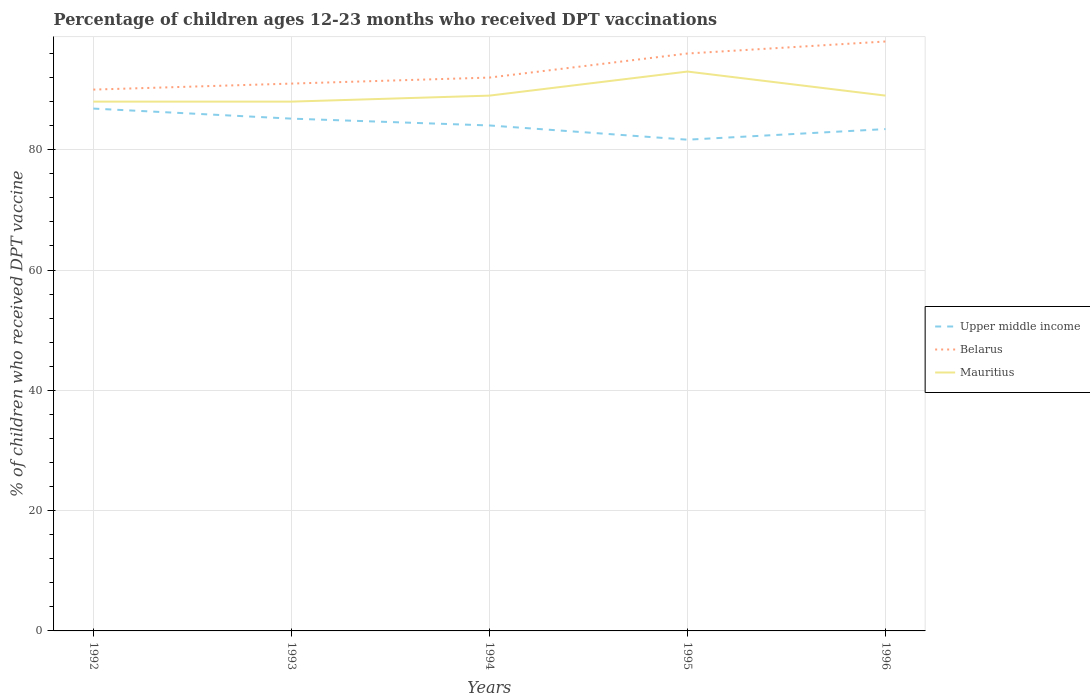How many different coloured lines are there?
Provide a succinct answer. 3. Does the line corresponding to Belarus intersect with the line corresponding to Mauritius?
Offer a very short reply. No. Is the number of lines equal to the number of legend labels?
Your answer should be very brief. Yes. Across all years, what is the maximum percentage of children who received DPT vaccination in Mauritius?
Provide a short and direct response. 88. What is the difference between the highest and the second highest percentage of children who received DPT vaccination in Mauritius?
Offer a terse response. 5. What is the difference between the highest and the lowest percentage of children who received DPT vaccination in Mauritius?
Your answer should be very brief. 1. Are the values on the major ticks of Y-axis written in scientific E-notation?
Offer a terse response. No. Does the graph contain any zero values?
Ensure brevity in your answer.  No. Does the graph contain grids?
Your answer should be compact. Yes. Where does the legend appear in the graph?
Keep it short and to the point. Center right. How many legend labels are there?
Make the answer very short. 3. How are the legend labels stacked?
Your answer should be very brief. Vertical. What is the title of the graph?
Give a very brief answer. Percentage of children ages 12-23 months who received DPT vaccinations. Does "Tuvalu" appear as one of the legend labels in the graph?
Ensure brevity in your answer.  No. What is the label or title of the X-axis?
Give a very brief answer. Years. What is the label or title of the Y-axis?
Give a very brief answer. % of children who received DPT vaccine. What is the % of children who received DPT vaccine in Upper middle income in 1992?
Make the answer very short. 86.84. What is the % of children who received DPT vaccine of Upper middle income in 1993?
Your response must be concise. 85.17. What is the % of children who received DPT vaccine in Belarus in 1993?
Your answer should be compact. 91. What is the % of children who received DPT vaccine in Mauritius in 1993?
Offer a terse response. 88. What is the % of children who received DPT vaccine in Upper middle income in 1994?
Keep it short and to the point. 84.04. What is the % of children who received DPT vaccine in Belarus in 1994?
Your answer should be very brief. 92. What is the % of children who received DPT vaccine of Mauritius in 1994?
Provide a succinct answer. 89. What is the % of children who received DPT vaccine in Upper middle income in 1995?
Provide a short and direct response. 81.67. What is the % of children who received DPT vaccine in Belarus in 1995?
Offer a terse response. 96. What is the % of children who received DPT vaccine of Mauritius in 1995?
Your answer should be compact. 93. What is the % of children who received DPT vaccine in Upper middle income in 1996?
Offer a terse response. 83.43. What is the % of children who received DPT vaccine of Mauritius in 1996?
Your answer should be very brief. 89. Across all years, what is the maximum % of children who received DPT vaccine in Upper middle income?
Give a very brief answer. 86.84. Across all years, what is the maximum % of children who received DPT vaccine of Mauritius?
Make the answer very short. 93. Across all years, what is the minimum % of children who received DPT vaccine of Upper middle income?
Your answer should be very brief. 81.67. Across all years, what is the minimum % of children who received DPT vaccine of Mauritius?
Your answer should be very brief. 88. What is the total % of children who received DPT vaccine of Upper middle income in the graph?
Your response must be concise. 421.16. What is the total % of children who received DPT vaccine of Belarus in the graph?
Provide a short and direct response. 467. What is the total % of children who received DPT vaccine in Mauritius in the graph?
Your response must be concise. 447. What is the difference between the % of children who received DPT vaccine in Upper middle income in 1992 and that in 1993?
Make the answer very short. 1.67. What is the difference between the % of children who received DPT vaccine in Belarus in 1992 and that in 1993?
Provide a succinct answer. -1. What is the difference between the % of children who received DPT vaccine of Mauritius in 1992 and that in 1993?
Your response must be concise. 0. What is the difference between the % of children who received DPT vaccine of Upper middle income in 1992 and that in 1994?
Make the answer very short. 2.81. What is the difference between the % of children who received DPT vaccine of Belarus in 1992 and that in 1994?
Keep it short and to the point. -2. What is the difference between the % of children who received DPT vaccine in Mauritius in 1992 and that in 1994?
Provide a succinct answer. -1. What is the difference between the % of children who received DPT vaccine of Upper middle income in 1992 and that in 1995?
Ensure brevity in your answer.  5.17. What is the difference between the % of children who received DPT vaccine of Belarus in 1992 and that in 1995?
Ensure brevity in your answer.  -6. What is the difference between the % of children who received DPT vaccine in Mauritius in 1992 and that in 1995?
Ensure brevity in your answer.  -5. What is the difference between the % of children who received DPT vaccine in Upper middle income in 1992 and that in 1996?
Keep it short and to the point. 3.41. What is the difference between the % of children who received DPT vaccine in Belarus in 1992 and that in 1996?
Provide a short and direct response. -8. What is the difference between the % of children who received DPT vaccine in Upper middle income in 1993 and that in 1994?
Provide a short and direct response. 1.13. What is the difference between the % of children who received DPT vaccine in Belarus in 1993 and that in 1994?
Your answer should be compact. -1. What is the difference between the % of children who received DPT vaccine in Upper middle income in 1993 and that in 1995?
Offer a terse response. 3.5. What is the difference between the % of children who received DPT vaccine in Mauritius in 1993 and that in 1995?
Offer a terse response. -5. What is the difference between the % of children who received DPT vaccine of Upper middle income in 1993 and that in 1996?
Provide a succinct answer. 1.74. What is the difference between the % of children who received DPT vaccine of Belarus in 1993 and that in 1996?
Offer a terse response. -7. What is the difference between the % of children who received DPT vaccine in Mauritius in 1993 and that in 1996?
Offer a very short reply. -1. What is the difference between the % of children who received DPT vaccine of Upper middle income in 1994 and that in 1995?
Ensure brevity in your answer.  2.37. What is the difference between the % of children who received DPT vaccine of Belarus in 1994 and that in 1995?
Keep it short and to the point. -4. What is the difference between the % of children who received DPT vaccine in Upper middle income in 1994 and that in 1996?
Your answer should be compact. 0.6. What is the difference between the % of children who received DPT vaccine of Belarus in 1994 and that in 1996?
Offer a terse response. -6. What is the difference between the % of children who received DPT vaccine in Upper middle income in 1995 and that in 1996?
Make the answer very short. -1.76. What is the difference between the % of children who received DPT vaccine in Mauritius in 1995 and that in 1996?
Offer a terse response. 4. What is the difference between the % of children who received DPT vaccine in Upper middle income in 1992 and the % of children who received DPT vaccine in Belarus in 1993?
Offer a very short reply. -4.16. What is the difference between the % of children who received DPT vaccine of Upper middle income in 1992 and the % of children who received DPT vaccine of Mauritius in 1993?
Give a very brief answer. -1.16. What is the difference between the % of children who received DPT vaccine in Belarus in 1992 and the % of children who received DPT vaccine in Mauritius in 1993?
Your answer should be very brief. 2. What is the difference between the % of children who received DPT vaccine of Upper middle income in 1992 and the % of children who received DPT vaccine of Belarus in 1994?
Provide a succinct answer. -5.16. What is the difference between the % of children who received DPT vaccine in Upper middle income in 1992 and the % of children who received DPT vaccine in Mauritius in 1994?
Offer a very short reply. -2.16. What is the difference between the % of children who received DPT vaccine of Upper middle income in 1992 and the % of children who received DPT vaccine of Belarus in 1995?
Keep it short and to the point. -9.16. What is the difference between the % of children who received DPT vaccine of Upper middle income in 1992 and the % of children who received DPT vaccine of Mauritius in 1995?
Your answer should be very brief. -6.16. What is the difference between the % of children who received DPT vaccine in Upper middle income in 1992 and the % of children who received DPT vaccine in Belarus in 1996?
Your answer should be compact. -11.16. What is the difference between the % of children who received DPT vaccine in Upper middle income in 1992 and the % of children who received DPT vaccine in Mauritius in 1996?
Make the answer very short. -2.16. What is the difference between the % of children who received DPT vaccine of Belarus in 1992 and the % of children who received DPT vaccine of Mauritius in 1996?
Give a very brief answer. 1. What is the difference between the % of children who received DPT vaccine of Upper middle income in 1993 and the % of children who received DPT vaccine of Belarus in 1994?
Offer a terse response. -6.83. What is the difference between the % of children who received DPT vaccine of Upper middle income in 1993 and the % of children who received DPT vaccine of Mauritius in 1994?
Offer a terse response. -3.83. What is the difference between the % of children who received DPT vaccine in Belarus in 1993 and the % of children who received DPT vaccine in Mauritius in 1994?
Ensure brevity in your answer.  2. What is the difference between the % of children who received DPT vaccine of Upper middle income in 1993 and the % of children who received DPT vaccine of Belarus in 1995?
Make the answer very short. -10.83. What is the difference between the % of children who received DPT vaccine in Upper middle income in 1993 and the % of children who received DPT vaccine in Mauritius in 1995?
Offer a very short reply. -7.83. What is the difference between the % of children who received DPT vaccine in Belarus in 1993 and the % of children who received DPT vaccine in Mauritius in 1995?
Provide a short and direct response. -2. What is the difference between the % of children who received DPT vaccine of Upper middle income in 1993 and the % of children who received DPT vaccine of Belarus in 1996?
Offer a very short reply. -12.83. What is the difference between the % of children who received DPT vaccine of Upper middle income in 1993 and the % of children who received DPT vaccine of Mauritius in 1996?
Ensure brevity in your answer.  -3.83. What is the difference between the % of children who received DPT vaccine in Belarus in 1993 and the % of children who received DPT vaccine in Mauritius in 1996?
Give a very brief answer. 2. What is the difference between the % of children who received DPT vaccine of Upper middle income in 1994 and the % of children who received DPT vaccine of Belarus in 1995?
Your answer should be very brief. -11.96. What is the difference between the % of children who received DPT vaccine in Upper middle income in 1994 and the % of children who received DPT vaccine in Mauritius in 1995?
Provide a succinct answer. -8.96. What is the difference between the % of children who received DPT vaccine of Upper middle income in 1994 and the % of children who received DPT vaccine of Belarus in 1996?
Ensure brevity in your answer.  -13.96. What is the difference between the % of children who received DPT vaccine in Upper middle income in 1994 and the % of children who received DPT vaccine in Mauritius in 1996?
Provide a short and direct response. -4.96. What is the difference between the % of children who received DPT vaccine of Upper middle income in 1995 and the % of children who received DPT vaccine of Belarus in 1996?
Your response must be concise. -16.33. What is the difference between the % of children who received DPT vaccine in Upper middle income in 1995 and the % of children who received DPT vaccine in Mauritius in 1996?
Make the answer very short. -7.33. What is the difference between the % of children who received DPT vaccine of Belarus in 1995 and the % of children who received DPT vaccine of Mauritius in 1996?
Provide a succinct answer. 7. What is the average % of children who received DPT vaccine of Upper middle income per year?
Offer a very short reply. 84.23. What is the average % of children who received DPT vaccine in Belarus per year?
Provide a short and direct response. 93.4. What is the average % of children who received DPT vaccine of Mauritius per year?
Ensure brevity in your answer.  89.4. In the year 1992, what is the difference between the % of children who received DPT vaccine in Upper middle income and % of children who received DPT vaccine in Belarus?
Offer a terse response. -3.16. In the year 1992, what is the difference between the % of children who received DPT vaccine in Upper middle income and % of children who received DPT vaccine in Mauritius?
Provide a succinct answer. -1.16. In the year 1993, what is the difference between the % of children who received DPT vaccine in Upper middle income and % of children who received DPT vaccine in Belarus?
Your response must be concise. -5.83. In the year 1993, what is the difference between the % of children who received DPT vaccine of Upper middle income and % of children who received DPT vaccine of Mauritius?
Keep it short and to the point. -2.83. In the year 1994, what is the difference between the % of children who received DPT vaccine of Upper middle income and % of children who received DPT vaccine of Belarus?
Your answer should be very brief. -7.96. In the year 1994, what is the difference between the % of children who received DPT vaccine in Upper middle income and % of children who received DPT vaccine in Mauritius?
Ensure brevity in your answer.  -4.96. In the year 1995, what is the difference between the % of children who received DPT vaccine of Upper middle income and % of children who received DPT vaccine of Belarus?
Your response must be concise. -14.33. In the year 1995, what is the difference between the % of children who received DPT vaccine of Upper middle income and % of children who received DPT vaccine of Mauritius?
Provide a succinct answer. -11.33. In the year 1996, what is the difference between the % of children who received DPT vaccine in Upper middle income and % of children who received DPT vaccine in Belarus?
Your answer should be compact. -14.57. In the year 1996, what is the difference between the % of children who received DPT vaccine in Upper middle income and % of children who received DPT vaccine in Mauritius?
Your answer should be very brief. -5.57. In the year 1996, what is the difference between the % of children who received DPT vaccine of Belarus and % of children who received DPT vaccine of Mauritius?
Provide a short and direct response. 9. What is the ratio of the % of children who received DPT vaccine in Upper middle income in 1992 to that in 1993?
Your response must be concise. 1.02. What is the ratio of the % of children who received DPT vaccine of Mauritius in 1992 to that in 1993?
Make the answer very short. 1. What is the ratio of the % of children who received DPT vaccine in Upper middle income in 1992 to that in 1994?
Keep it short and to the point. 1.03. What is the ratio of the % of children who received DPT vaccine in Belarus in 1992 to that in 1994?
Make the answer very short. 0.98. What is the ratio of the % of children who received DPT vaccine in Upper middle income in 1992 to that in 1995?
Your response must be concise. 1.06. What is the ratio of the % of children who received DPT vaccine in Mauritius in 1992 to that in 1995?
Provide a succinct answer. 0.95. What is the ratio of the % of children who received DPT vaccine in Upper middle income in 1992 to that in 1996?
Your answer should be very brief. 1.04. What is the ratio of the % of children who received DPT vaccine of Belarus in 1992 to that in 1996?
Ensure brevity in your answer.  0.92. What is the ratio of the % of children who received DPT vaccine in Mauritius in 1992 to that in 1996?
Offer a terse response. 0.99. What is the ratio of the % of children who received DPT vaccine of Upper middle income in 1993 to that in 1994?
Offer a very short reply. 1.01. What is the ratio of the % of children who received DPT vaccine in Upper middle income in 1993 to that in 1995?
Ensure brevity in your answer.  1.04. What is the ratio of the % of children who received DPT vaccine of Belarus in 1993 to that in 1995?
Make the answer very short. 0.95. What is the ratio of the % of children who received DPT vaccine in Mauritius in 1993 to that in 1995?
Provide a short and direct response. 0.95. What is the ratio of the % of children who received DPT vaccine of Upper middle income in 1993 to that in 1996?
Offer a very short reply. 1.02. What is the ratio of the % of children who received DPT vaccine of Belarus in 1993 to that in 1996?
Keep it short and to the point. 0.93. What is the ratio of the % of children who received DPT vaccine of Mauritius in 1993 to that in 1996?
Your answer should be very brief. 0.99. What is the ratio of the % of children who received DPT vaccine of Belarus in 1994 to that in 1995?
Offer a very short reply. 0.96. What is the ratio of the % of children who received DPT vaccine of Mauritius in 1994 to that in 1995?
Provide a succinct answer. 0.96. What is the ratio of the % of children who received DPT vaccine in Belarus in 1994 to that in 1996?
Your response must be concise. 0.94. What is the ratio of the % of children who received DPT vaccine in Upper middle income in 1995 to that in 1996?
Your answer should be compact. 0.98. What is the ratio of the % of children who received DPT vaccine of Belarus in 1995 to that in 1996?
Your answer should be very brief. 0.98. What is the ratio of the % of children who received DPT vaccine of Mauritius in 1995 to that in 1996?
Give a very brief answer. 1.04. What is the difference between the highest and the second highest % of children who received DPT vaccine of Upper middle income?
Provide a short and direct response. 1.67. What is the difference between the highest and the second highest % of children who received DPT vaccine in Mauritius?
Provide a succinct answer. 4. What is the difference between the highest and the lowest % of children who received DPT vaccine in Upper middle income?
Ensure brevity in your answer.  5.17. 